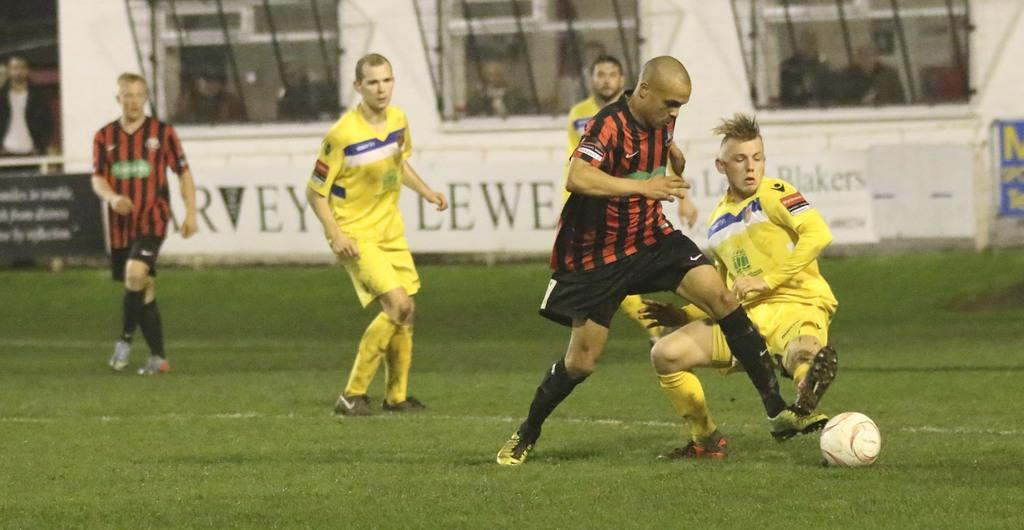<image>
Relay a brief, clear account of the picture shown. two teams playing soccer with an ad featuring the word blakers behind them to the right 